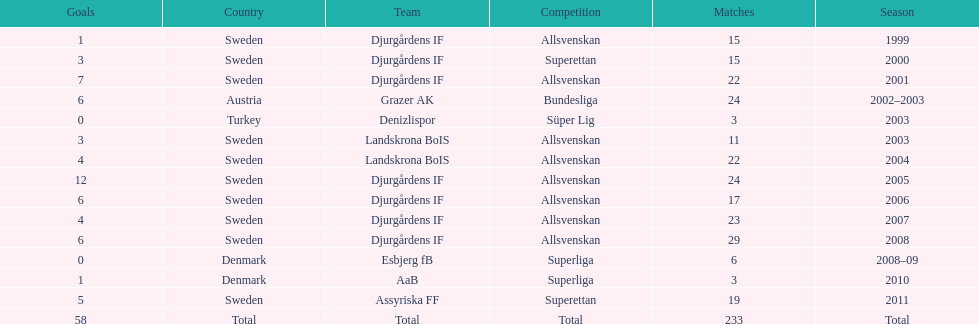How many total goals has jones kusi-asare scored? 58. 